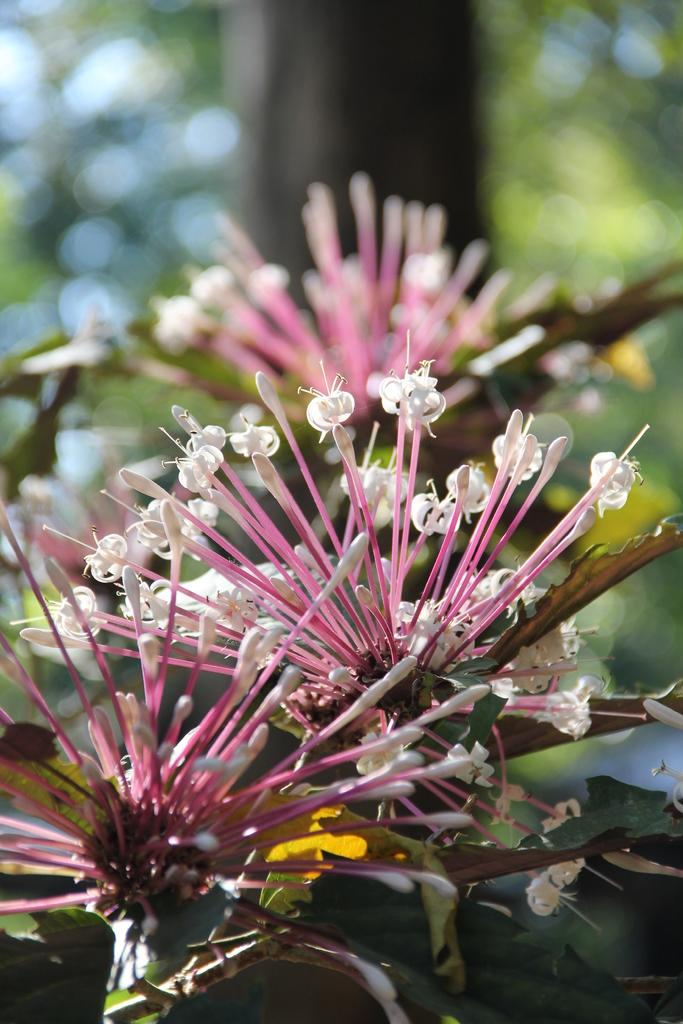What is located in the foreground of the image? There are flowers in the foreground of the image. What is the flowers' connection to a larger organism? The flowers are associated with a plant. What can be seen in the background of the image? There is a tree in the background of the image. What type of knot is being tied by the tree in the image? There is no knot-tying activity depicted in the image; it features flowers in the foreground and a tree in the background. 